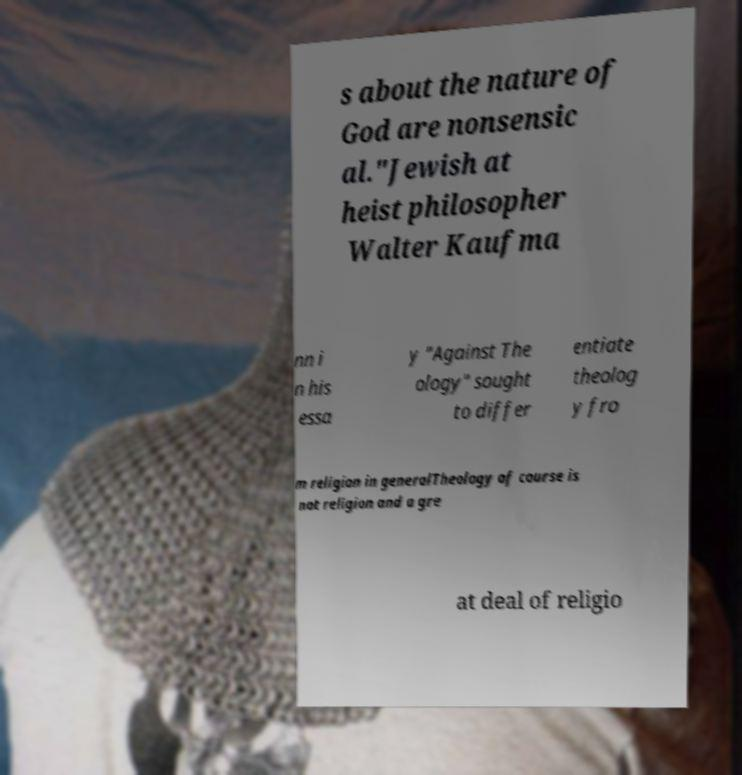Could you assist in decoding the text presented in this image and type it out clearly? s about the nature of God are nonsensic al."Jewish at heist philosopher Walter Kaufma nn i n his essa y "Against The ology" sought to differ entiate theolog y fro m religion in generalTheology of course is not religion and a gre at deal of religio 